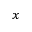Convert formula to latex. <formula><loc_0><loc_0><loc_500><loc_500>_ { x }</formula> 